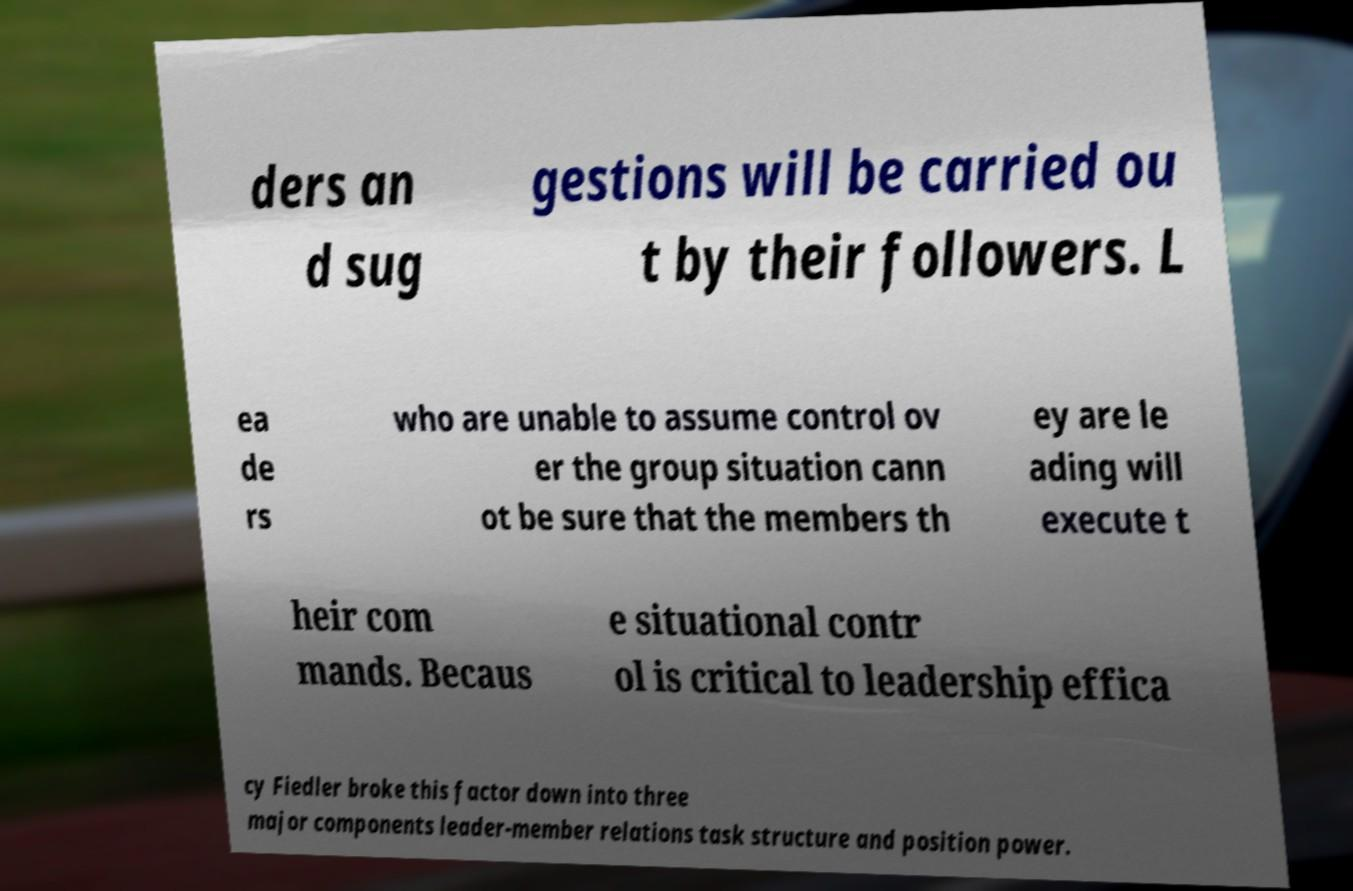What messages or text are displayed in this image? I need them in a readable, typed format. ders an d sug gestions will be carried ou t by their followers. L ea de rs who are unable to assume control ov er the group situation cann ot be sure that the members th ey are le ading will execute t heir com mands. Becaus e situational contr ol is critical to leadership effica cy Fiedler broke this factor down into three major components leader-member relations task structure and position power. 